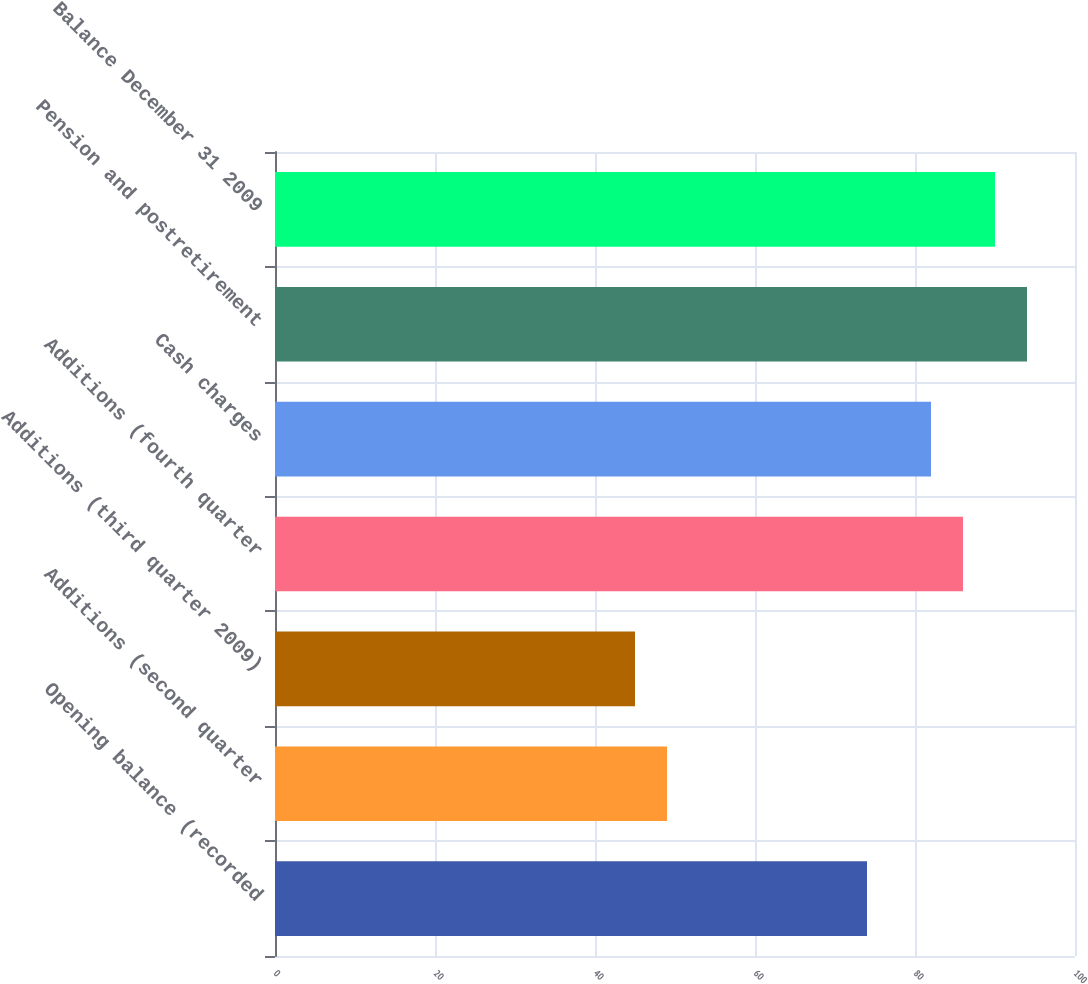Convert chart to OTSL. <chart><loc_0><loc_0><loc_500><loc_500><bar_chart><fcel>Opening balance (recorded<fcel>Additions (second quarter<fcel>Additions (third quarter 2009)<fcel>Additions (fourth quarter<fcel>Cash charges<fcel>Pension and postretirement<fcel>Balance December 31 2009<nl><fcel>74<fcel>49<fcel>45<fcel>86<fcel>82<fcel>94<fcel>90<nl></chart> 